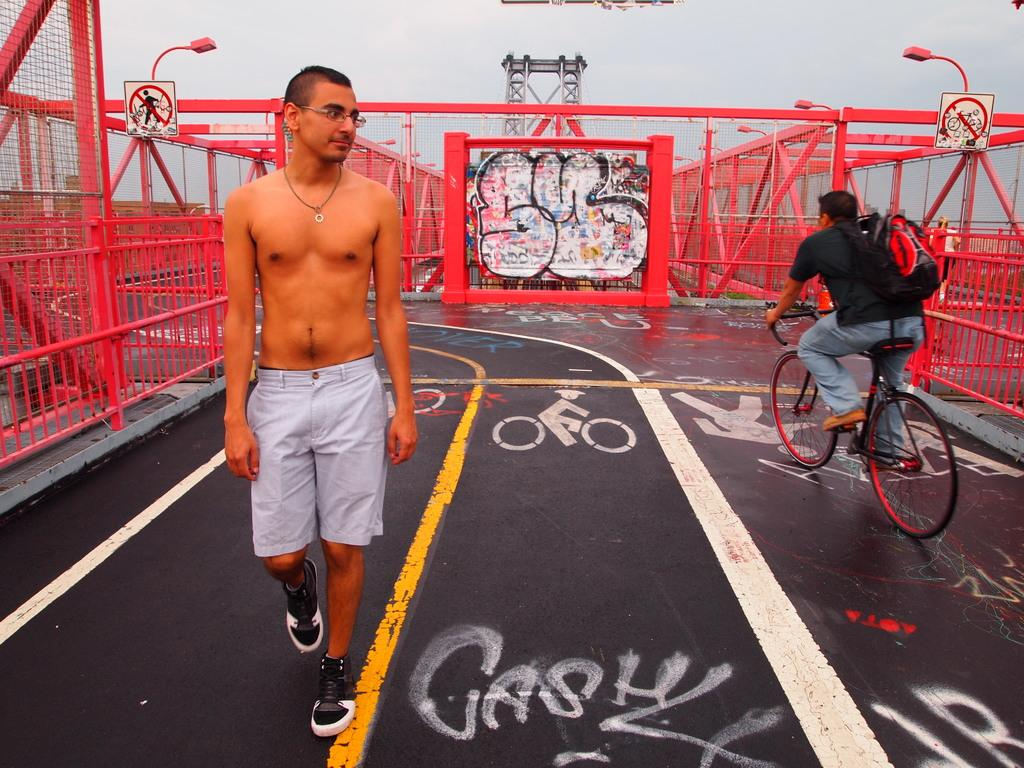Who is present in the image? There is a man in the image. What is the man doing in the image? The man is walking on the road. What accessory is the man wearing in the image? The man is wearing spectacles. What mode of transportation can be seen in the image? There is a person on a bicycle in the image. What part of the natural environment is visible in the image? The sky is visible in the image. What type of comb does the man's grandmother use in the image? There is no mention of a comb or the man's grandmother in the image. 